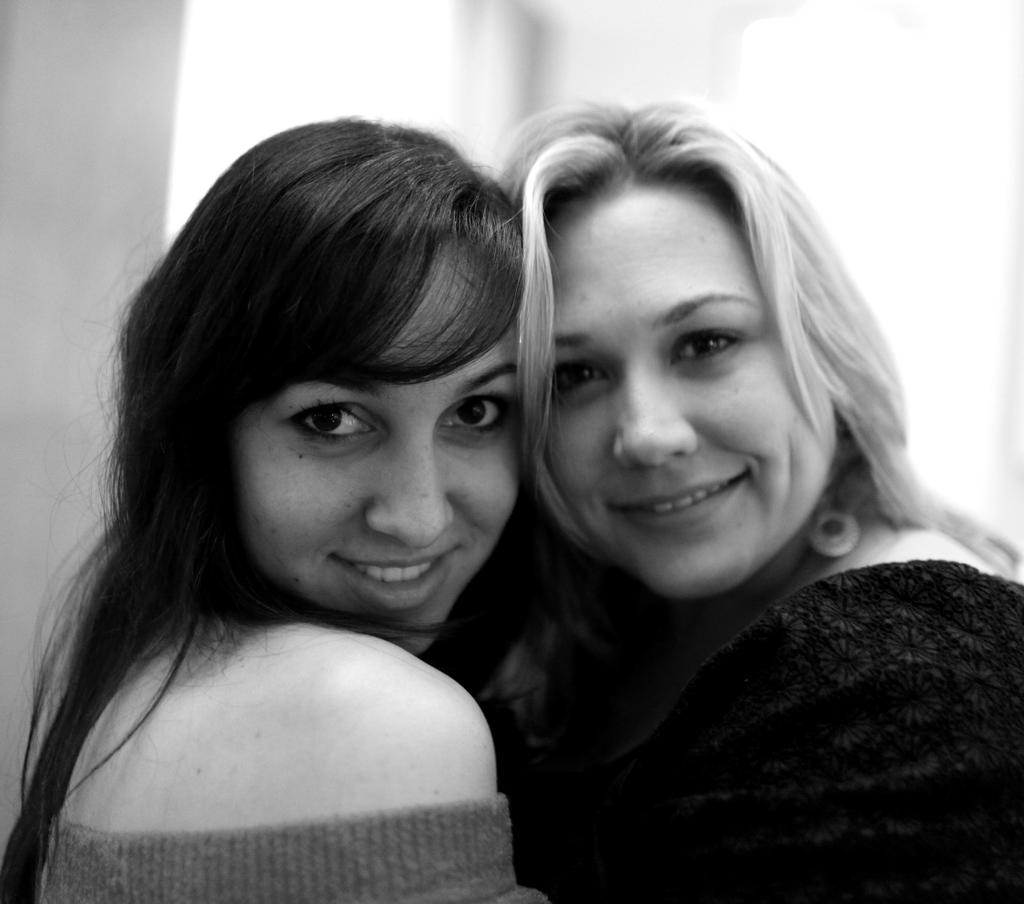How many people are in the image? There are two ladies in the image. What are the two ladies doing in the image? The two ladies are hugging each other. What type of dinner is being served in the image? There is no dinner present in the image; it features two ladies hugging each other. Can you see the moon in the image? There is no moon visible in the image. 